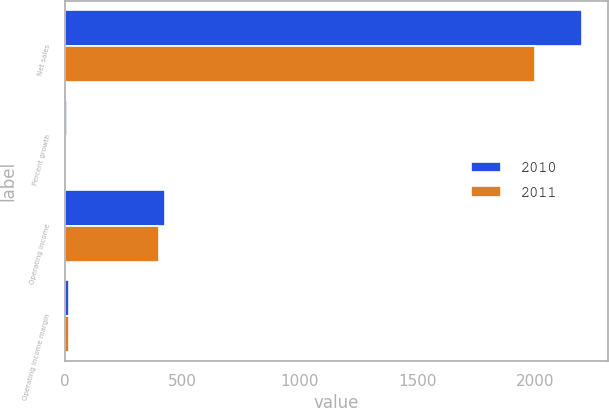<chart> <loc_0><loc_0><loc_500><loc_500><stacked_bar_chart><ecel><fcel>Net sales<fcel>Percent growth<fcel>Operating income<fcel>Operating income margin<nl><fcel>2010<fcel>2199.9<fcel>10<fcel>428.4<fcel>19.5<nl><fcel>2011<fcel>1999<fcel>4.6<fcel>402.4<fcel>20.1<nl></chart> 